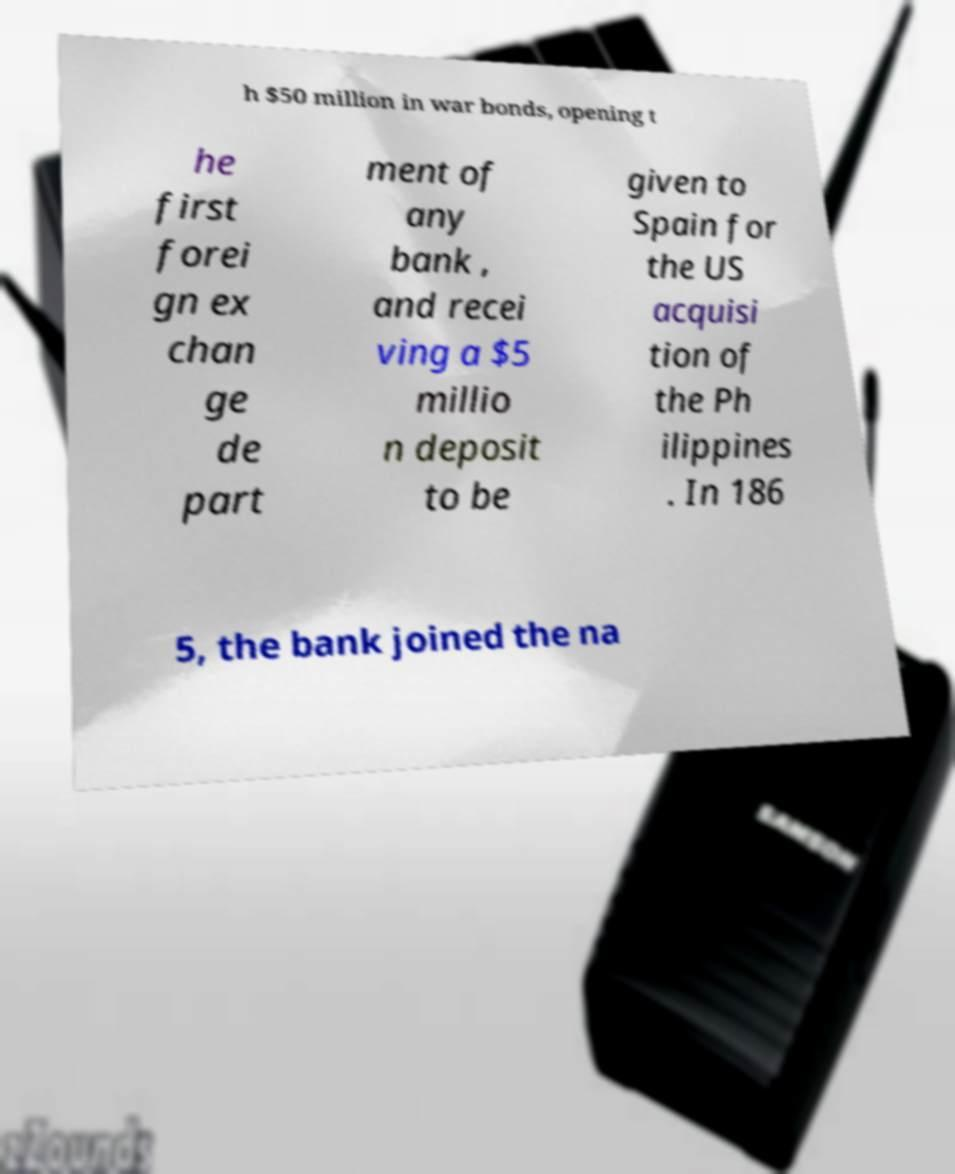For documentation purposes, I need the text within this image transcribed. Could you provide that? h $50 million in war bonds, opening t he first forei gn ex chan ge de part ment of any bank , and recei ving a $5 millio n deposit to be given to Spain for the US acquisi tion of the Ph ilippines . In 186 5, the bank joined the na 